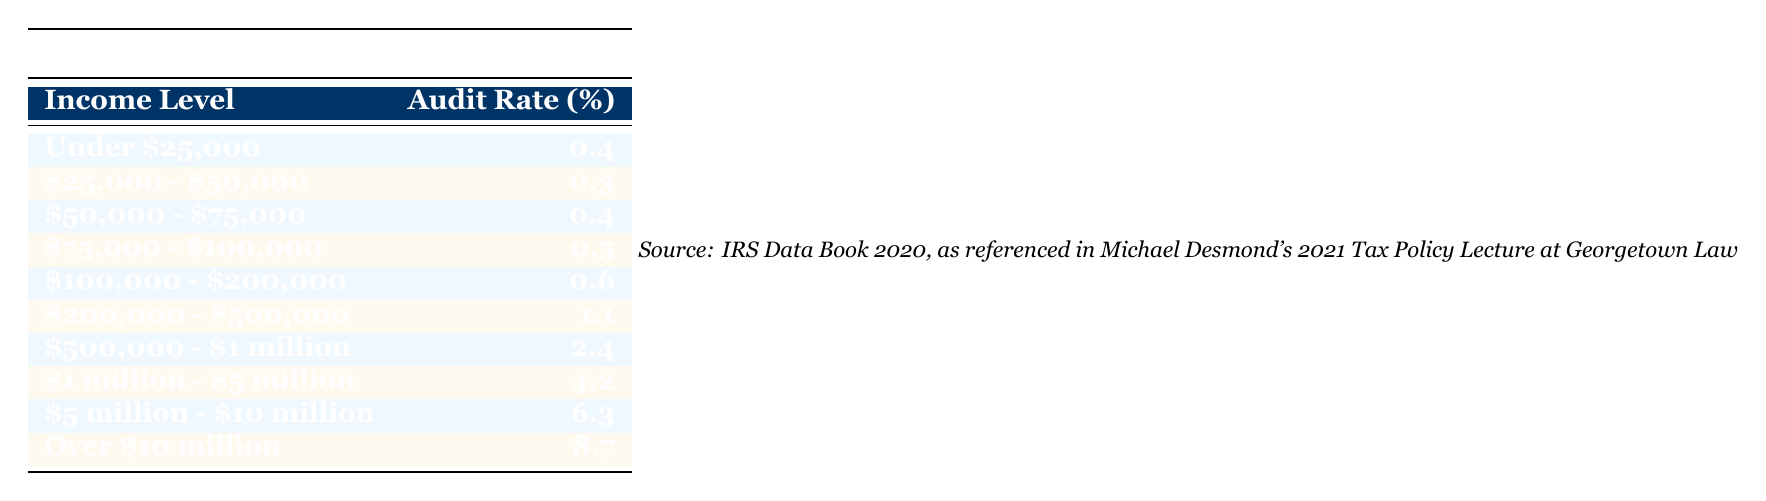What is the audit rate for taxpayers earning $100,000 to $200,000? The table lists an audit rate of 0.6% for the income level of $100,000 to $200,000.
Answer: 0.6 Which income level has the highest audit rate? According to the table, the income level "Over $10 million" has the highest audit rate at 8.7%.
Answer: Over $10 million What is the average audit rate for income levels under $50,000? The audit rates for income levels "Under $25,000" (0.4%) and "$25,000 - $50,000" (0.3%) need to be averaged. The sum is 0.4 + 0.3 = 0.7, and dividing by 2 gives an average of 0.35%.
Answer: 0.35 Is there an income level with an audit rate of 2.0%? By inspecting the table, no income level shows an audit rate of exactly 2.0%. The closest values are 2.4% and 1.1%.
Answer: No What is the total audit rate for income levels of $500,000 and above? The audit rates for the income levels "$500,000 - $1 million" (2.4%), "$1 million - $5 million" (4.2%), "$5 million - $10 million" (6.3%), and "Over $10 million" (8.7%) need to be summed: 2.4 + 4.2 + 6.3 + 8.7 = 21.6%.
Answer: 21.6 How does the audit rate of those earning between $75,000 and $100,000 compare to those making between $50,000 and $75,000? The rate for "$75,000 - $100,000" is 0.5% and for "$50,000 - $75,000" is 0.4%. Since 0.5% is greater than 0.4%, it can be said that the former is higher compared to the latter.
Answer: The audit rate is higher for $75,000 - $100,000 Are there any income levels with an audit rate below 1%? By reviewing the table, the audit rates for "Under $25,000" (0.4%), "$25,000 - $50,000" (0.3%), "$50,000 - $75,000" (0.4%), "$75,000 - $100,000" (0.5%), and "$100,000 - $200,000" (0.6%) are all below 1%.
Answer: Yes 